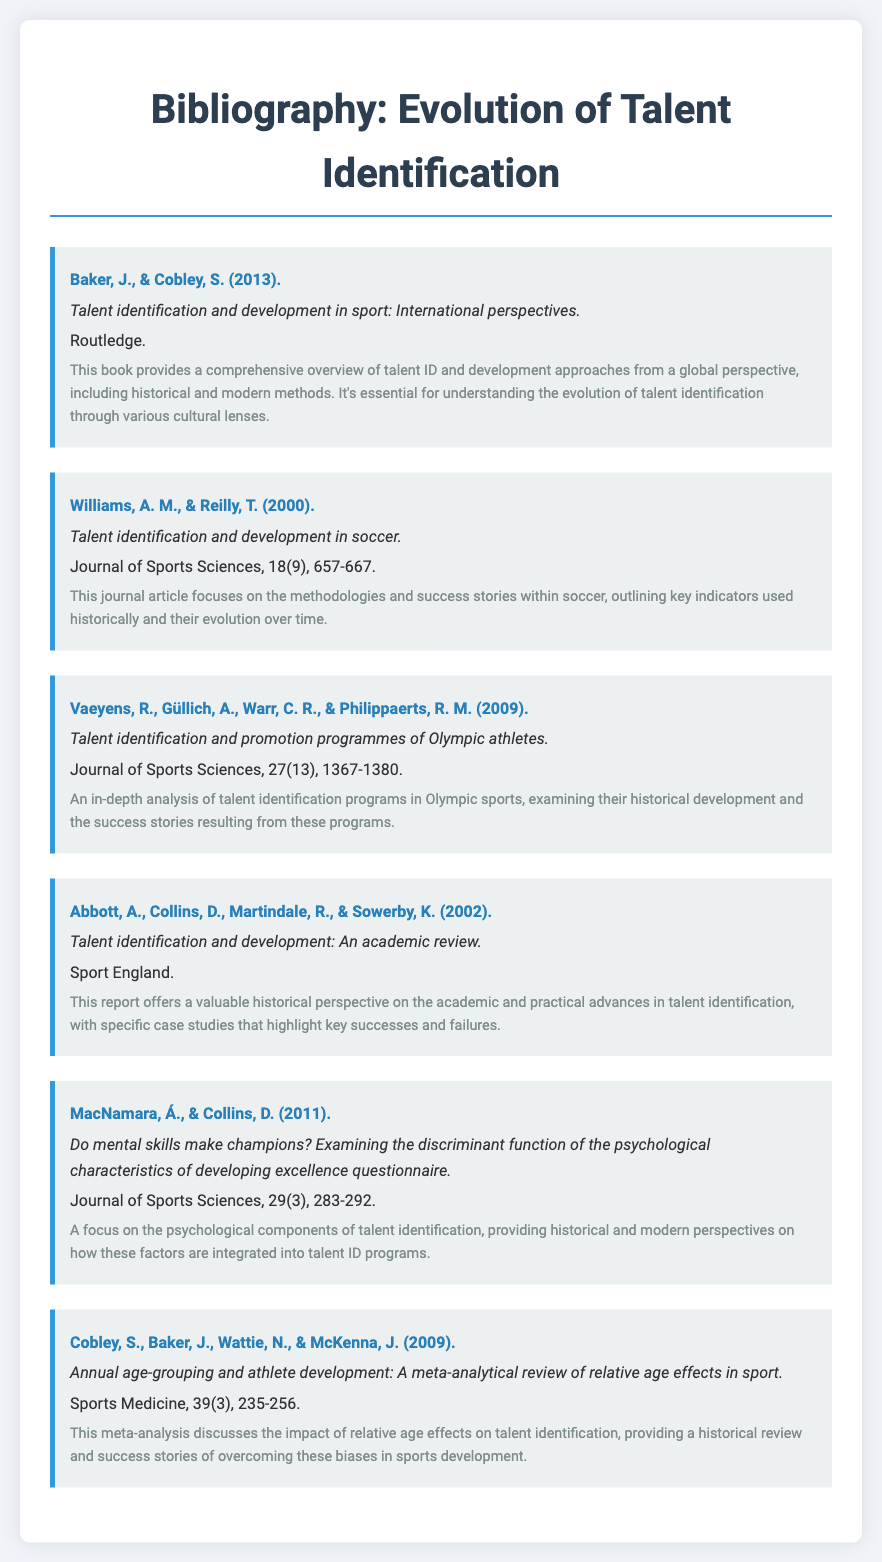What is the title of the first entry? The title of the first entry is provided after the author's names, which is "Talent identification and development in sport: International perspectives."
Answer: Talent identification and development in sport: International perspectives Who are the authors of the third entry? The authors of the third entry are listed before the title, who are "Vaeyens, R., Güllich, A., Warr, C. R., & Philippaerts, R. M."
Answer: Vaeyens, R., Güllich, A., Warr, C. R., & Philippaerts, R. M What year was the article by Williams and Reilly published? The publication year is stated in parentheses after the authors' names, which is 2000.
Answer: 2000 What is the primary focus of the article by MacNamara and Collins? The focus of the article is briefly described in the notes section following the title, which discusses the psychological components of talent identification.
Answer: Psychological components of talent identification How many authors contributed to the entry titled "Annual age-grouping and athlete development"? The number of authors is determined by counting the names listed before the title, which are four authors.
Answer: Four authors What type of document is provided by Abbott et al. 2002? The type of document is indicated by the title and the context in which it is presented, which is a report.
Answer: Report 